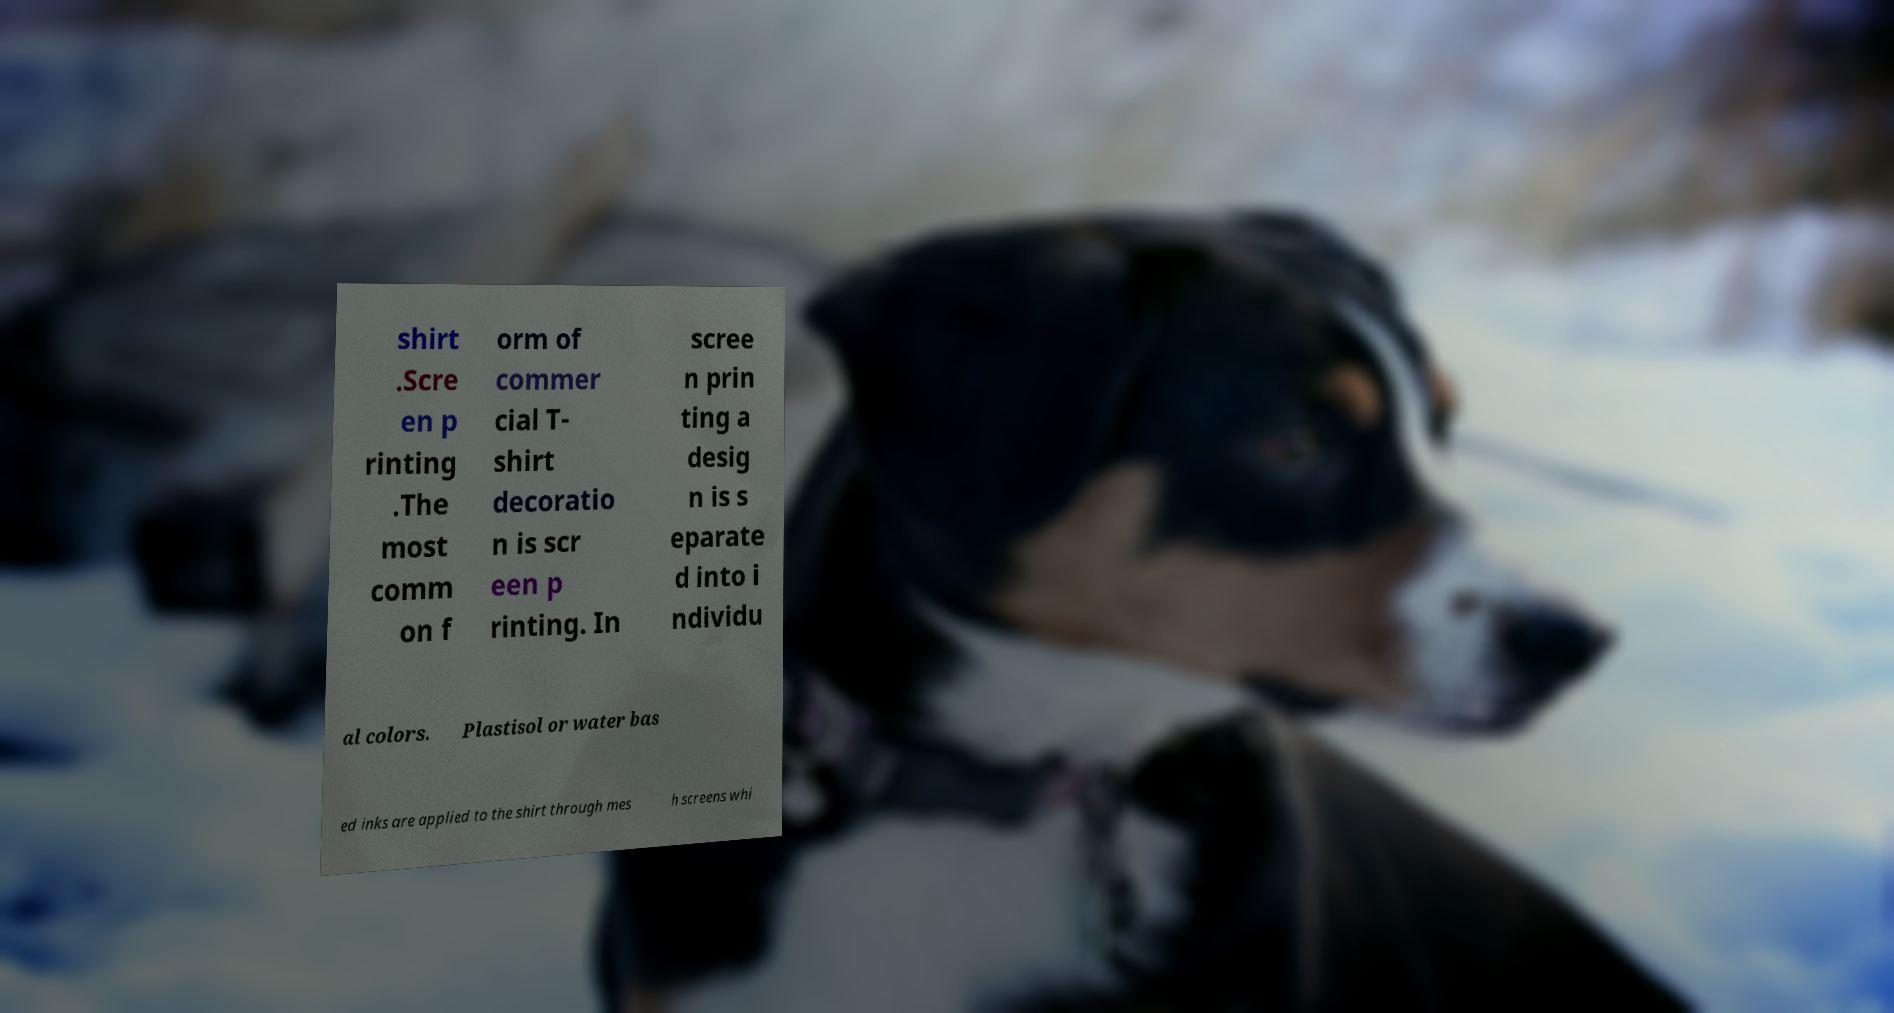Please identify and transcribe the text found in this image. shirt .Scre en p rinting .The most comm on f orm of commer cial T- shirt decoratio n is scr een p rinting. In scree n prin ting a desig n is s eparate d into i ndividu al colors. Plastisol or water bas ed inks are applied to the shirt through mes h screens whi 